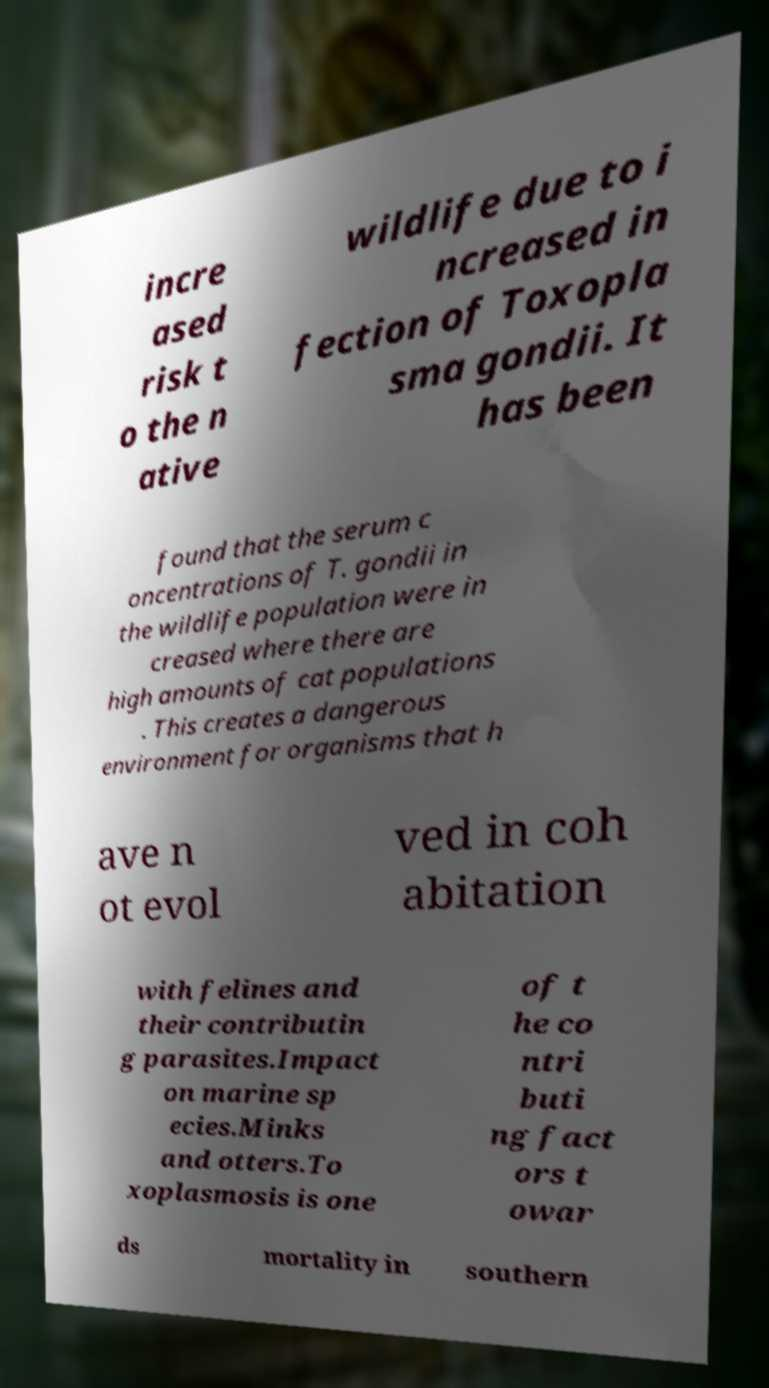I need the written content from this picture converted into text. Can you do that? incre ased risk t o the n ative wildlife due to i ncreased in fection of Toxopla sma gondii. It has been found that the serum c oncentrations of T. gondii in the wildlife population were in creased where there are high amounts of cat populations . This creates a dangerous environment for organisms that h ave n ot evol ved in coh abitation with felines and their contributin g parasites.Impact on marine sp ecies.Minks and otters.To xoplasmosis is one of t he co ntri buti ng fact ors t owar ds mortality in southern 